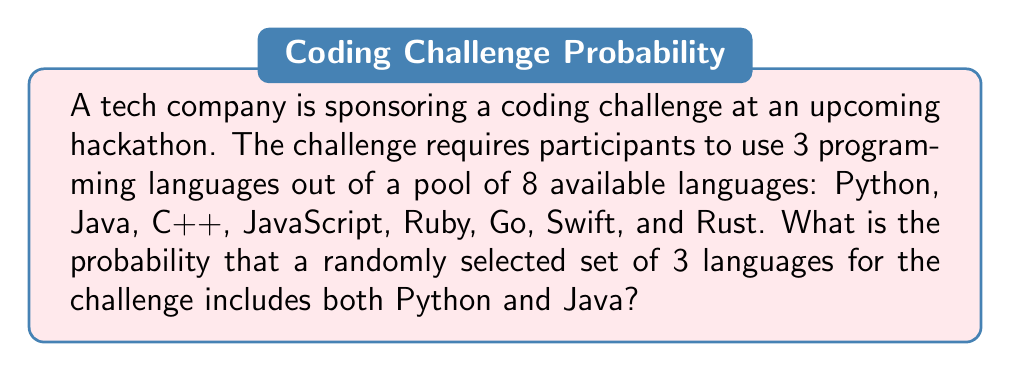Can you answer this question? To solve this problem, we'll use the concept of combinations and the probability formula:

$$ P(\text{event}) = \frac{\text{favorable outcomes}}{\text{total possible outcomes}} $$

Step 1: Calculate the total number of possible outcomes.
The total number of ways to select 3 languages out of 8 is given by the combination formula:

$$ \binom{8}{3} = \frac{8!}{3!(8-3)!} = \frac{8!}{3!5!} = 56 $$

Step 2: Calculate the number of favorable outcomes.
We need to select Python and Java, plus one more language from the remaining 6. This is equivalent to choosing 1 language out of 6:

$$ \binom{6}{1} = 6 $$

Step 3: Apply the probability formula.

$$ P(\text{Python and Java included}) = \frac{\text{favorable outcomes}}{\text{total possible outcomes}} = \frac{6}{56} = \frac{3}{28} \approx 0.1071 $$

Therefore, the probability of randomly selecting a set of 3 languages that includes both Python and Java is $\frac{3}{28}$ or approximately 10.71%.
Answer: $\frac{3}{28}$ or approximately 0.1071 (10.71%) 